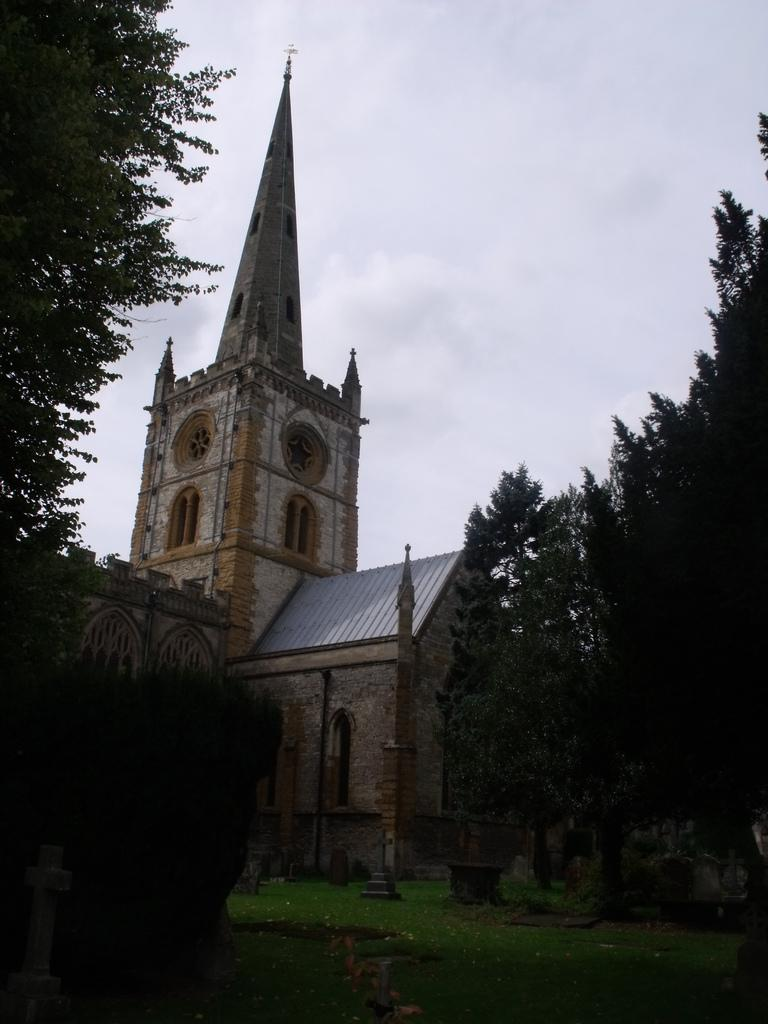What type of vegetation can be seen in the image? There are trees in the image. What type of structures are present in the image? There are buildings in the image. What type of ground cover is visible in the image? There is grass in the image. What is visible in the background of the image? The sky is visible in the image. How many boats are visible in the image? There are no boats present in the image. What type of can is being offered in the image? There is no can present in the image, and therefore no offer can be made. 